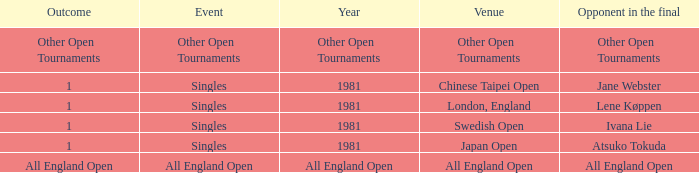What is the Outcome of the Singles Event in London, England? 1.0. 